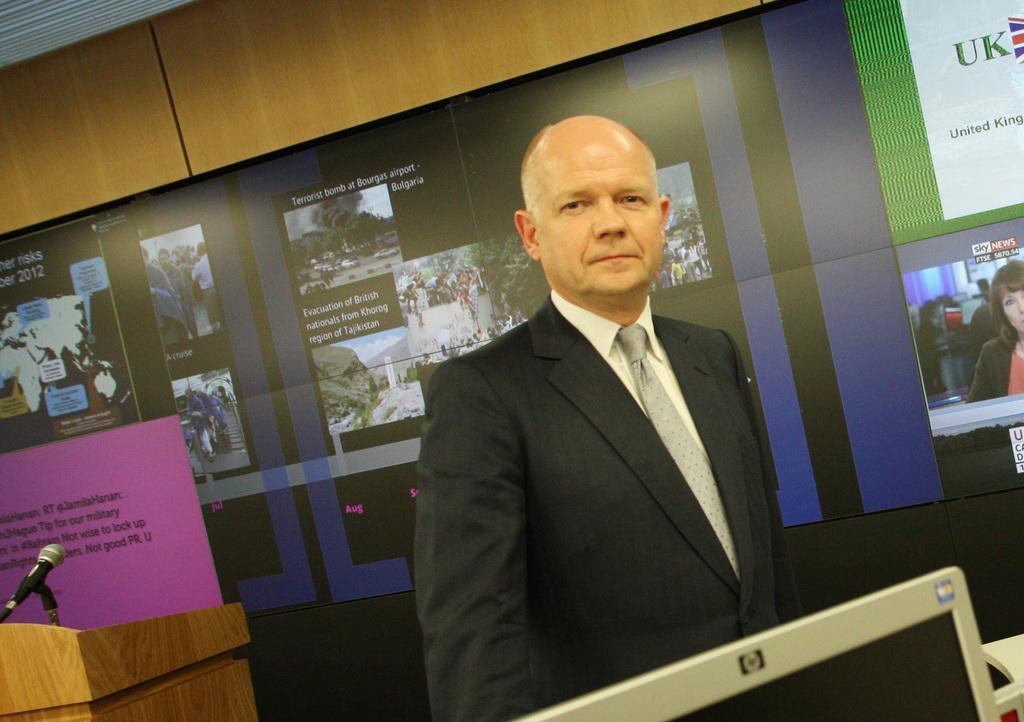Please provide a concise description of this image. A person is standing wearing a suit. There is a microphone and its stand at the left. There are posters at the back. 